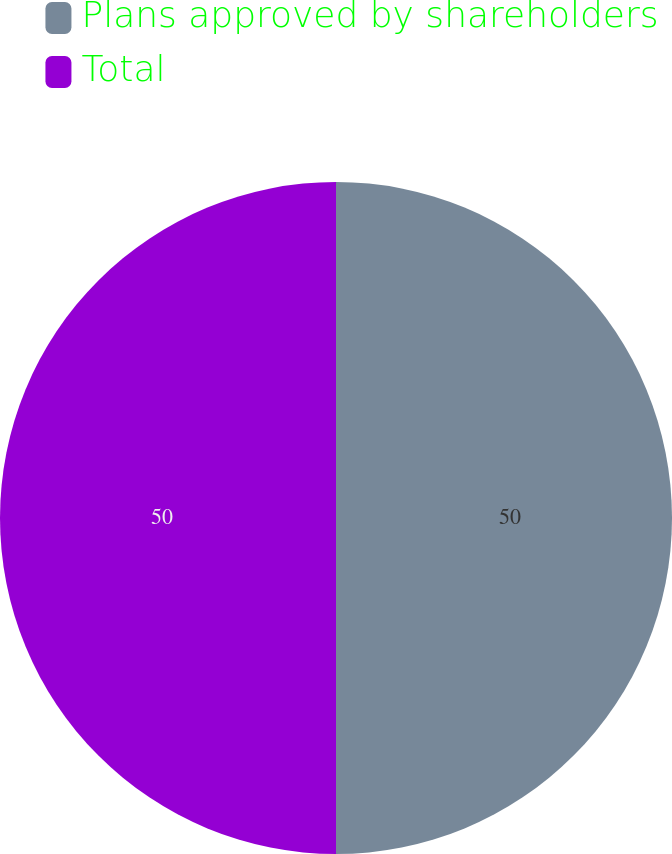Convert chart to OTSL. <chart><loc_0><loc_0><loc_500><loc_500><pie_chart><fcel>Plans approved by shareholders<fcel>Total<nl><fcel>50.0%<fcel>50.0%<nl></chart> 